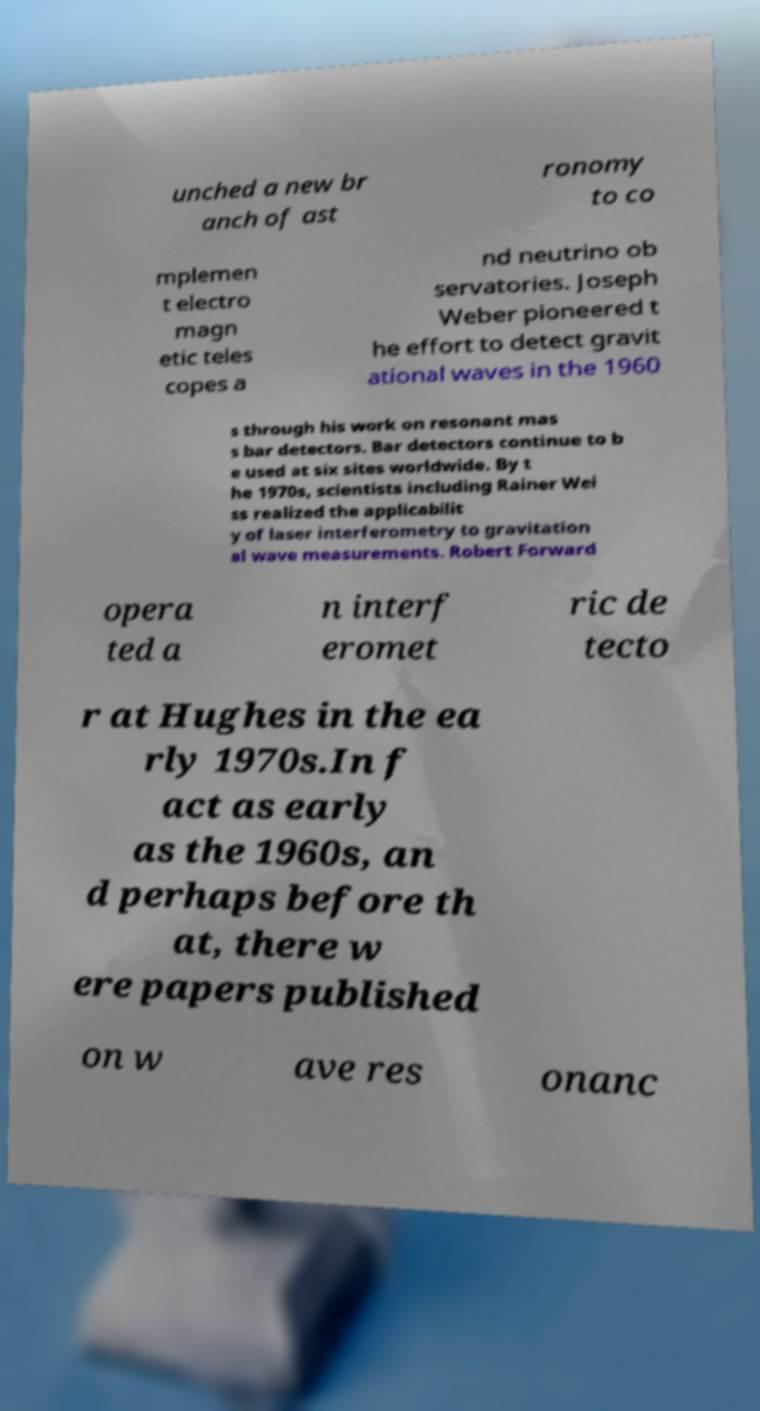Could you assist in decoding the text presented in this image and type it out clearly? unched a new br anch of ast ronomy to co mplemen t electro magn etic teles copes a nd neutrino ob servatories. Joseph Weber pioneered t he effort to detect gravit ational waves in the 1960 s through his work on resonant mas s bar detectors. Bar detectors continue to b e used at six sites worldwide. By t he 1970s, scientists including Rainer Wei ss realized the applicabilit y of laser interferometry to gravitation al wave measurements. Robert Forward opera ted a n interf eromet ric de tecto r at Hughes in the ea rly 1970s.In f act as early as the 1960s, an d perhaps before th at, there w ere papers published on w ave res onanc 